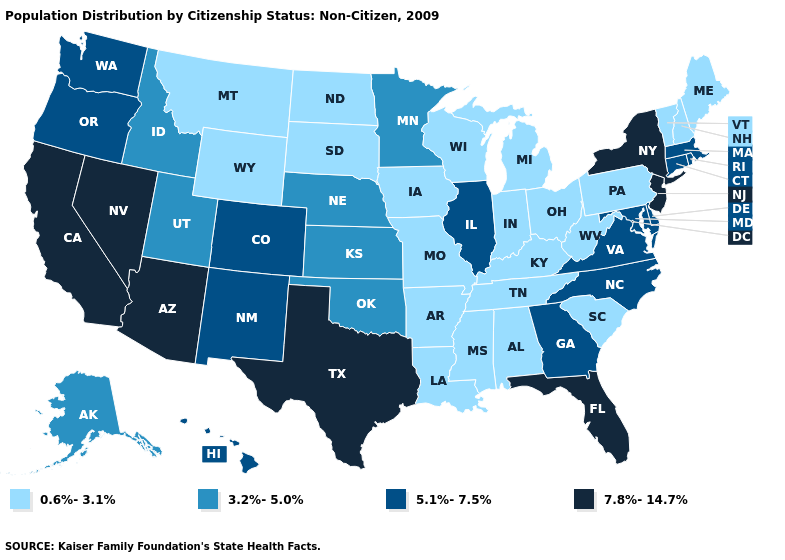Name the states that have a value in the range 7.8%-14.7%?
Quick response, please. Arizona, California, Florida, Nevada, New Jersey, New York, Texas. Among the states that border Georgia , does South Carolina have the lowest value?
Concise answer only. Yes. Does Florida have the highest value in the South?
Keep it brief. Yes. Which states have the highest value in the USA?
Answer briefly. Arizona, California, Florida, Nevada, New Jersey, New York, Texas. Among the states that border Ohio , which have the lowest value?
Short answer required. Indiana, Kentucky, Michigan, Pennsylvania, West Virginia. Does the map have missing data?
Be succinct. No. Does New York have a lower value than Oklahoma?
Concise answer only. No. How many symbols are there in the legend?
Give a very brief answer. 4. What is the value of Montana?
Be succinct. 0.6%-3.1%. Which states hav the highest value in the West?
Answer briefly. Arizona, California, Nevada. Name the states that have a value in the range 0.6%-3.1%?
Give a very brief answer. Alabama, Arkansas, Indiana, Iowa, Kentucky, Louisiana, Maine, Michigan, Mississippi, Missouri, Montana, New Hampshire, North Dakota, Ohio, Pennsylvania, South Carolina, South Dakota, Tennessee, Vermont, West Virginia, Wisconsin, Wyoming. Name the states that have a value in the range 0.6%-3.1%?
Quick response, please. Alabama, Arkansas, Indiana, Iowa, Kentucky, Louisiana, Maine, Michigan, Mississippi, Missouri, Montana, New Hampshire, North Dakota, Ohio, Pennsylvania, South Carolina, South Dakota, Tennessee, Vermont, West Virginia, Wisconsin, Wyoming. What is the highest value in the MidWest ?
Write a very short answer. 5.1%-7.5%. Does Illinois have a lower value than Nevada?
Give a very brief answer. Yes. Name the states that have a value in the range 0.6%-3.1%?
Be succinct. Alabama, Arkansas, Indiana, Iowa, Kentucky, Louisiana, Maine, Michigan, Mississippi, Missouri, Montana, New Hampshire, North Dakota, Ohio, Pennsylvania, South Carolina, South Dakota, Tennessee, Vermont, West Virginia, Wisconsin, Wyoming. 